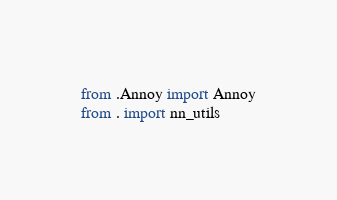Convert code to text. <code><loc_0><loc_0><loc_500><loc_500><_Python_>from .Annoy import Annoy
from . import nn_utils</code> 